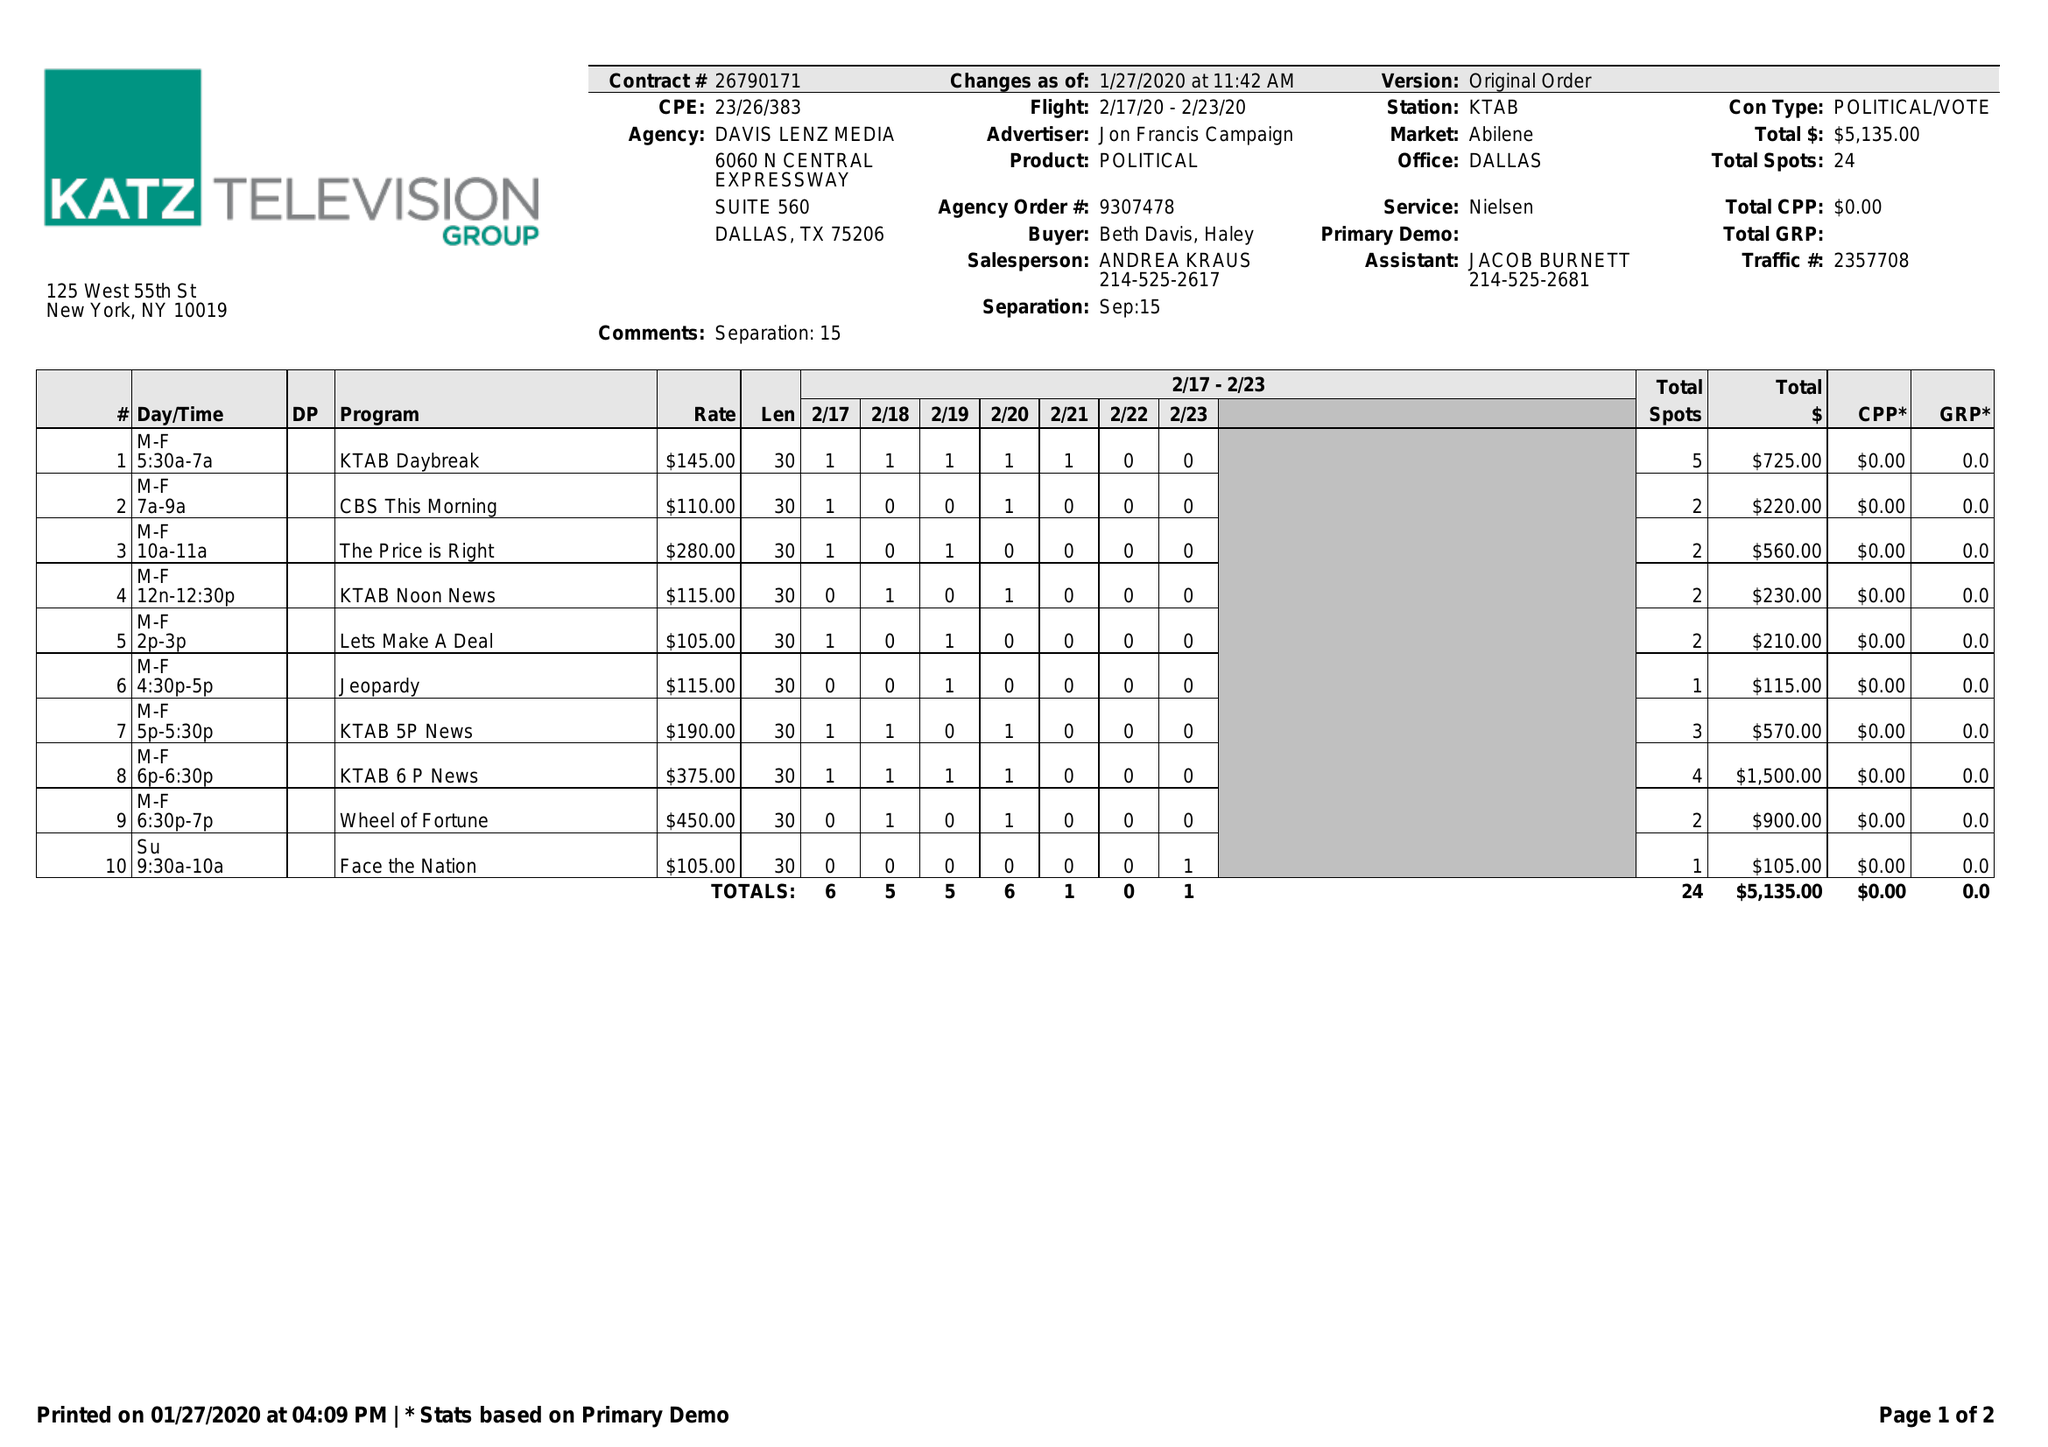What is the value for the gross_amount?
Answer the question using a single word or phrase. 5135.00 